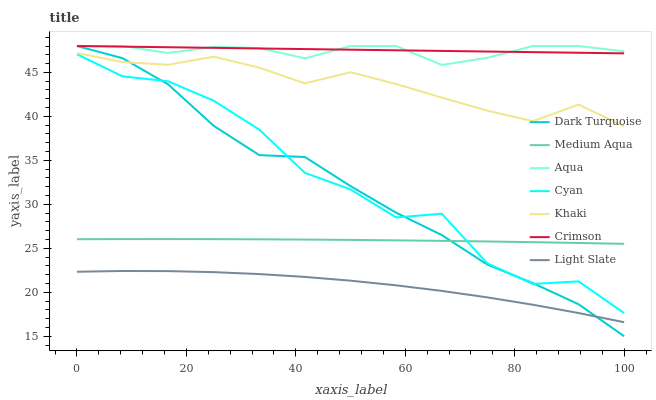Does Dark Turquoise have the minimum area under the curve?
Answer yes or no. No. Does Dark Turquoise have the maximum area under the curve?
Answer yes or no. No. Is Light Slate the smoothest?
Answer yes or no. No. Is Light Slate the roughest?
Answer yes or no. No. Does Light Slate have the lowest value?
Answer yes or no. No. Does Light Slate have the highest value?
Answer yes or no. No. Is Light Slate less than Crimson?
Answer yes or no. Yes. Is Crimson greater than Light Slate?
Answer yes or no. Yes. Does Light Slate intersect Crimson?
Answer yes or no. No. 